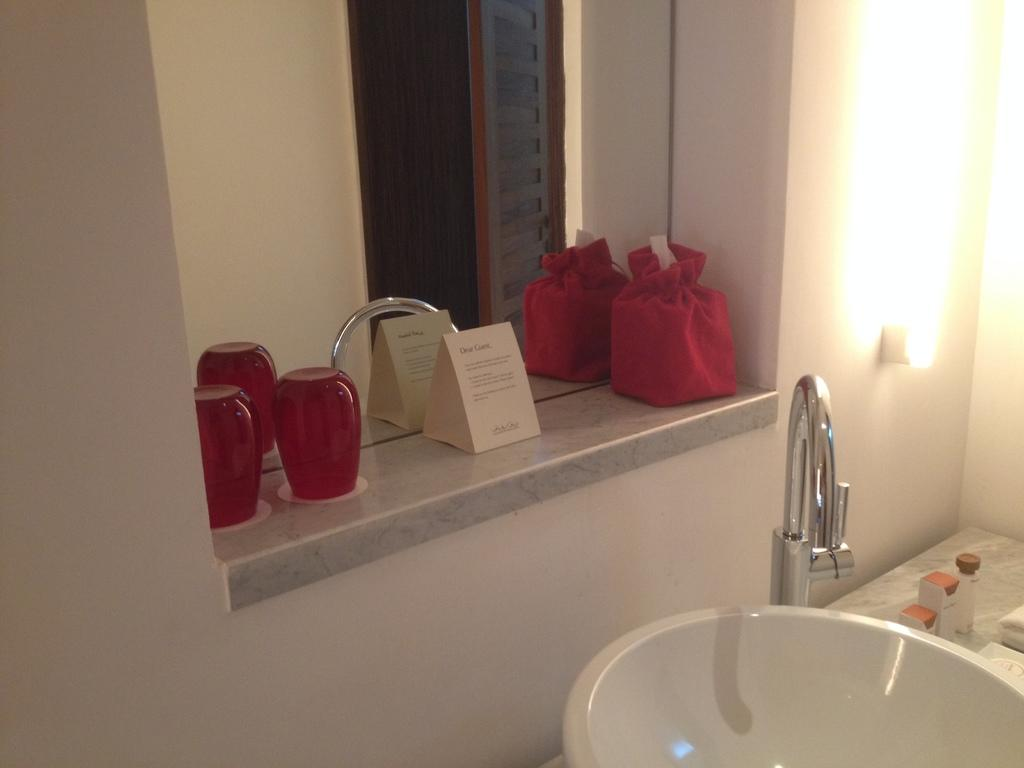What is one of the objects in the image that reflects light? There is a mirror in the image that reflects light. What type of lights can be seen in the image? There are decor lights and regular lights in the image. What is the purpose of the tap in the image? The tap is likely used for controlling water flow, as it is located near a sink in the image. What is the sink used for in the image? The sink is likely used for washing hands or cleaning objects, as it is located near a tap. What is the background of the image made of? There is a wall in the image, which serves as the background. How many attempts does the ornament make to fly in the image? There is no ornament present in the image, and therefore no such activity can be observed. What type of cannon is visible in the image? There is no cannon present in the image. 